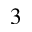<formula> <loc_0><loc_0><loc_500><loc_500>^ { 3 }</formula> 